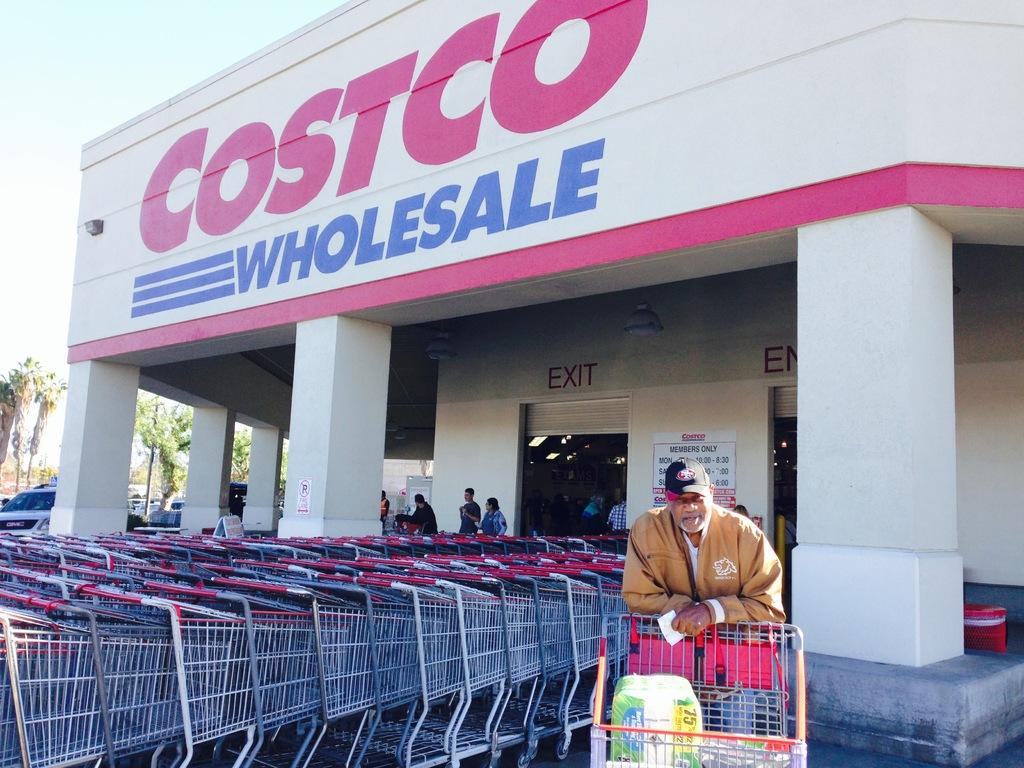Who or what is present in the image? There are people in the image. What objects can be seen in the image? There are carts and cars in the image. What type of vegetation is visible in the image? There are trees in the image. What is the color of the wall in the image? The wall in the image is white. What is visible at the top of the image? The sky is visible at the top of the image. Can you tell me how the moon affects the people in the image? The image does not show the moon or any influence it might have on the people. What type of pain is being experienced by the people in the image? There is no indication of pain or discomfort being experienced by the people in the image. 